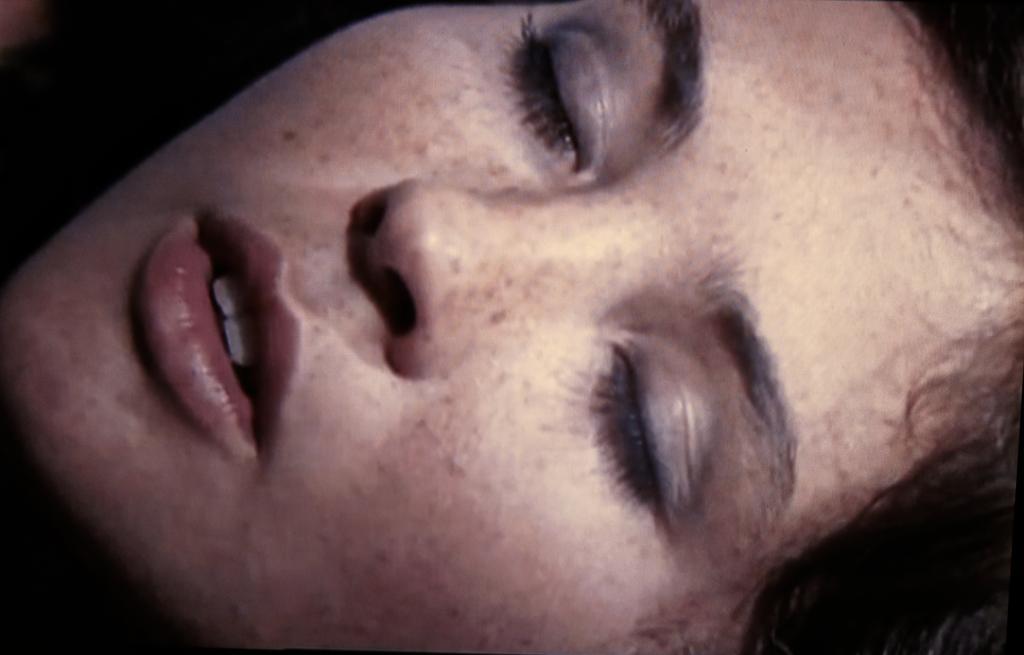In one or two sentences, can you explain what this image depicts? In this image we can see a person's face with eyes closed. 